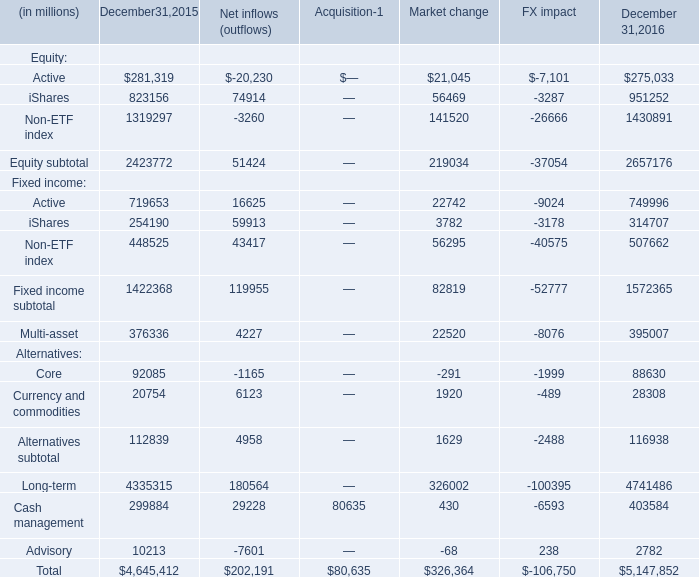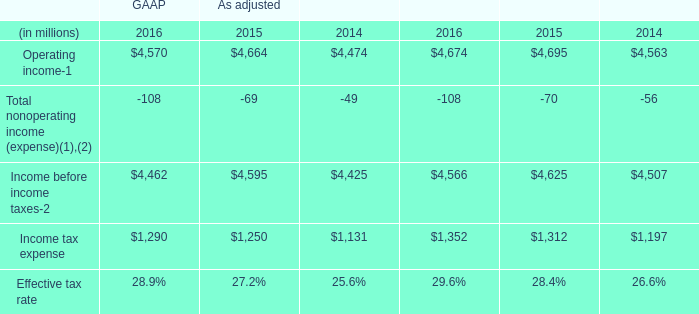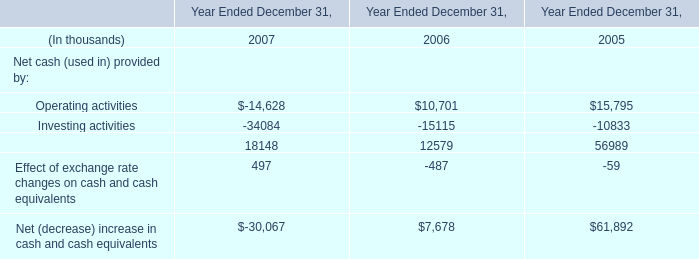What's the average of iShares of Equity on December 31, 2015 and December 31, 2016? (in million) 
Computations: ((823156 + 951252) / 2)
Answer: 887204.0. 